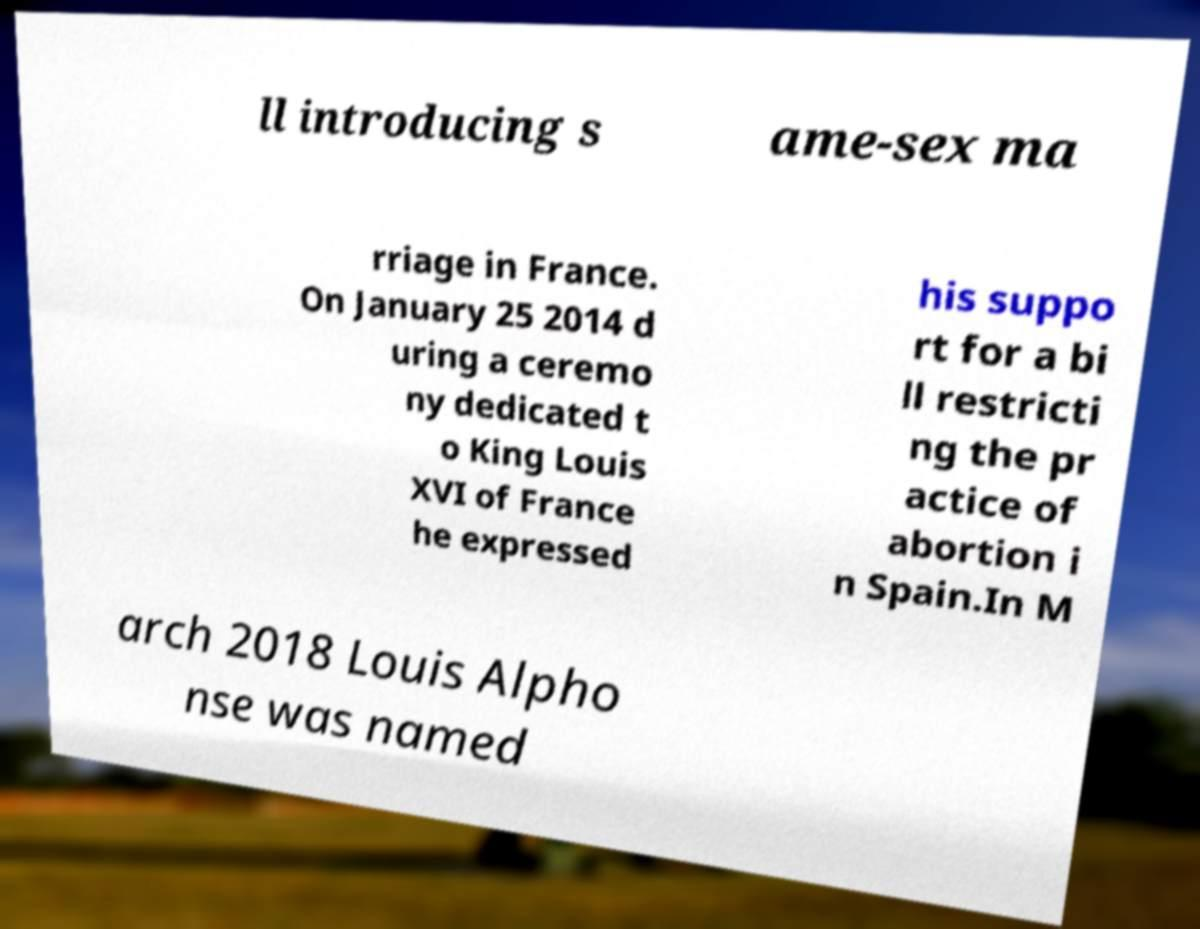Please read and relay the text visible in this image. What does it say? ll introducing s ame-sex ma rriage in France. On January 25 2014 d uring a ceremo ny dedicated t o King Louis XVI of France he expressed his suppo rt for a bi ll restricti ng the pr actice of abortion i n Spain.In M arch 2018 Louis Alpho nse was named 